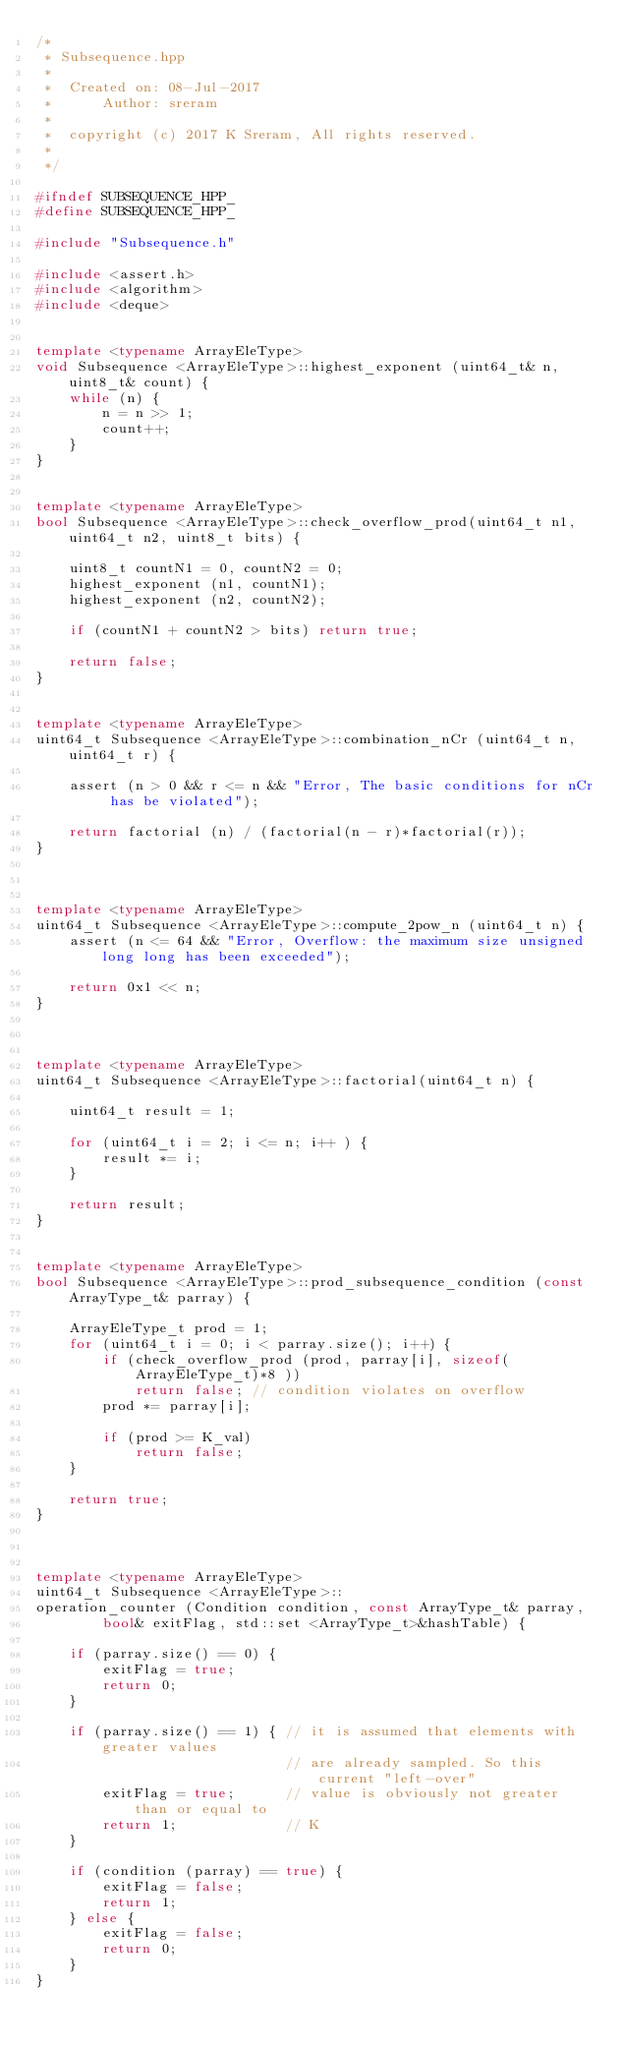<code> <loc_0><loc_0><loc_500><loc_500><_C++_>/*
 * Subsequence.hpp
 *
 *  Created on: 08-Jul-2017
 *      Author: sreram
 *
 *  copyright (c) 2017 K Sreram, All rights reserved.
 *
 */

#ifndef SUBSEQUENCE_HPP_
#define SUBSEQUENCE_HPP_

#include "Subsequence.h"

#include <assert.h>
#include <algorithm>
#include <deque>


template <typename ArrayEleType>
void Subsequence <ArrayEleType>::highest_exponent (uint64_t& n, uint8_t& count) {
	while (n) {
		n = n >> 1;
		count++;
	}
}


template <typename ArrayEleType>
bool Subsequence <ArrayEleType>::check_overflow_prod(uint64_t n1, uint64_t n2, uint8_t bits) {

	uint8_t countN1 = 0, countN2 = 0;
	highest_exponent (n1, countN1);
	highest_exponent (n2, countN2);

	if (countN1 + countN2 > bits) return true;

	return false;
}


template <typename ArrayEleType>
uint64_t Subsequence <ArrayEleType>::combination_nCr (uint64_t n, uint64_t r) {

	assert (n > 0 && r <= n && "Error, The basic conditions for nCr has be violated");

	return factorial (n) / (factorial(n - r)*factorial(r));
}



template <typename ArrayEleType>
uint64_t Subsequence <ArrayEleType>::compute_2pow_n (uint64_t n) {
	assert (n <= 64 && "Error, Overflow: the maximum size unsigned long long has been exceeded");

	return 0x1 << n;
}



template <typename ArrayEleType>
uint64_t Subsequence <ArrayEleType>::factorial(uint64_t n) {

	uint64_t result = 1;

	for (uint64_t i = 2; i <= n; i++ ) {
		result *= i;
	}

	return result;
}


template <typename ArrayEleType>
bool Subsequence <ArrayEleType>::prod_subsequence_condition (const ArrayType_t& parray) {

	ArrayEleType_t prod = 1;
	for (uint64_t i = 0; i < parray.size(); i++) {
		if (check_overflow_prod (prod, parray[i], sizeof(ArrayEleType_t)*8 ))
			return false; // condition violates on overflow
		prod *= parray[i];

		if (prod >= K_val)
			return false;
	}

	return true;
}



template <typename ArrayEleType>
uint64_t Subsequence <ArrayEleType>::
operation_counter (Condition condition, const ArrayType_t& parray,
		bool& exitFlag, std::set <ArrayType_t>&hashTable) {

	if (parray.size() == 0) {
		exitFlag = true;
		return 0;
	}

	if (parray.size() == 1) { // it is assumed that elements with greater values
							  // are already sampled. So this current "left-over"
		exitFlag = true;	  // value is obviously not greater than or equal to
		return 1;		      // K
	}

	if (condition (parray) == true) {
		exitFlag = false;
		return 1;
	} else {
		exitFlag = false;
		return 0;
	}
}
</code> 